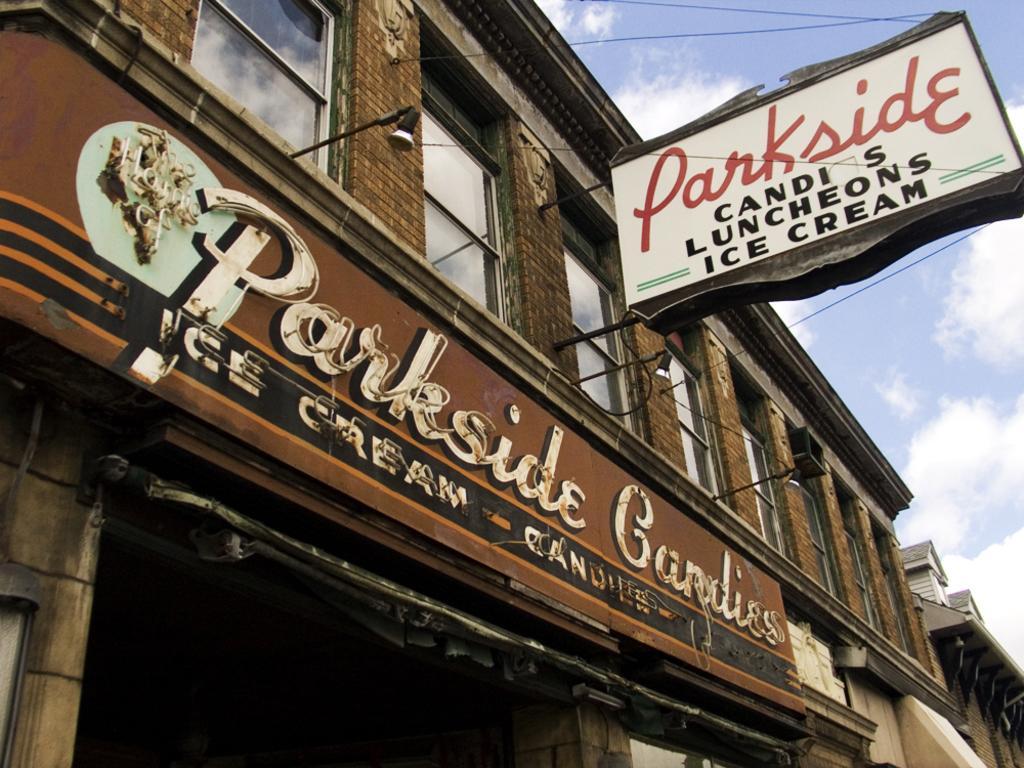Please provide a concise description of this image. In this picture, we can see a few buildings, we can see a building with windows, some posters attached to it is highlighted, and we can see the sky with clouds. 